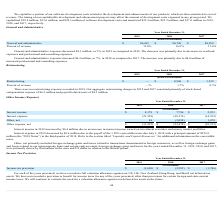According to Cornerstone Ondemand's financial document, What does others, net include? foreign exchange gains and losses related to transactions denominated in foreign currencies, as well as foreign exchange gains and losses related to our intercompany loans and certain cash accounts.. The document states: "Other, net primarily included foreign exchange gains and losses related to transactions denominated in foreign currencies, as well as foreign exchange..." Also, What was interest income in 2017? According to the financial document, $2,951 (in thousands). The relevant text states: "Interest income $ 8,178 $ 7,796 $ 2,951..." Also, What was others, net in 2019? According to the financial document, 84 (in thousands). The relevant text states: "Other, net 84 (3,098) 1,478..." Also, can you calculate: What was the percentage change in Interest expense between 2017 and 2018? To answer this question, I need to perform calculations using the financial data. The calculation is: (-28,176-(-14,762))/(-14,762), which equals 90.87 (percentage). This is based on the information: "Interest expense (21,559) (28,176) (14,762) Interest expense (21,559) (28,176) (14,762)..." The key data points involved are: 14,762, 28,176. Also, can you calculate: What is the average interest income from 2017-2019? To answer this question, I need to perform calculations using the financial data. The calculation is: ($8,178+$7,796+$2,951)/(2019-2017+1), which equals 6308.33 (in thousands). This is based on the information: "Interest income $ 8,178 $ 7,796 $ 2,951 Interest income $ 8,178 $ 7,796 $ 2,951 Interest income $ 8,178 $ 7,796 $ 2,951..." The key data points involved are: 2,951, 7,796, 8,178. Also, can you calculate: What was the percentage change in interest income between 2018 and 2019? To answer this question, I need to perform calculations using the financial data. The calculation is: ($8,178-$7,796)/$7,796, which equals 4.9 (percentage). This is based on the information: "Interest income $ 8,178 $ 7,796 $ 2,951 Interest income $ 8,178 $ 7,796 $ 2,951..." The key data points involved are: 7,796, 8,178. 